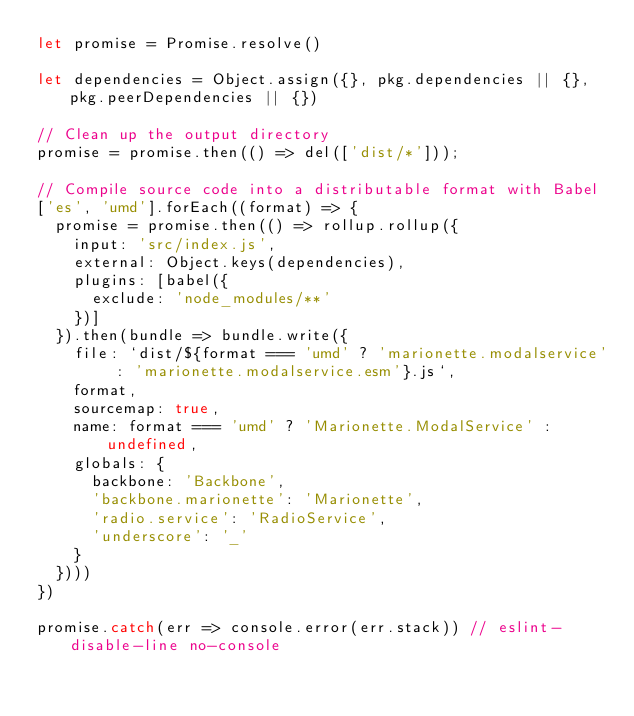Convert code to text. <code><loc_0><loc_0><loc_500><loc_500><_JavaScript_>let promise = Promise.resolve()

let dependencies = Object.assign({}, pkg.dependencies || {}, pkg.peerDependencies || {})

// Clean up the output directory
promise = promise.then(() => del(['dist/*']));

// Compile source code into a distributable format with Babel
['es', 'umd'].forEach((format) => {
  promise = promise.then(() => rollup.rollup({
    input: 'src/index.js',
    external: Object.keys(dependencies),
    plugins: [babel({
      exclude: 'node_modules/**'
    })]
  }).then(bundle => bundle.write({
    file: `dist/${format === 'umd' ? 'marionette.modalservice' : 'marionette.modalservice.esm'}.js`,
    format,
    sourcemap: true,
    name: format === 'umd' ? 'Marionette.ModalService' : undefined,
    globals: {
      backbone: 'Backbone',
      'backbone.marionette': 'Marionette',
      'radio.service': 'RadioService',
      'underscore': '_'
    }
  })))
})

promise.catch(err => console.error(err.stack)) // eslint-disable-line no-console
</code> 